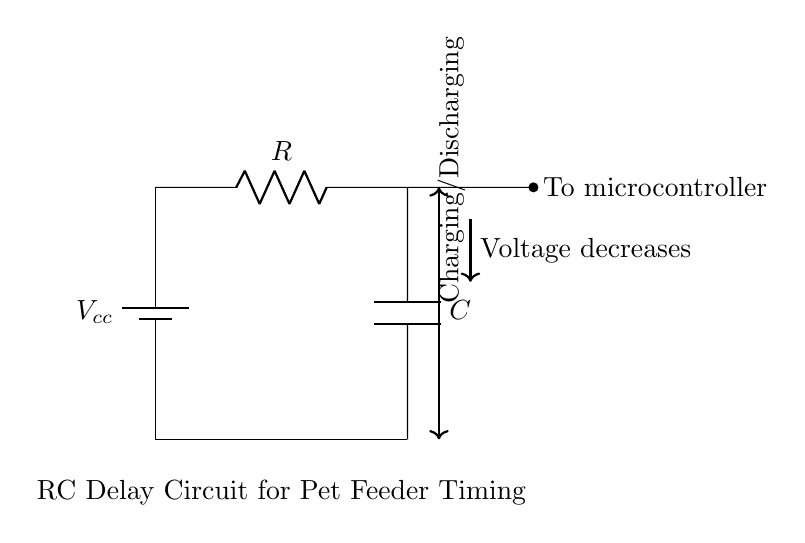What is the power source in this circuit? The circuit shows a battery symbol labeled as Vcc, indicating that the power source is a battery providing voltage to the circuit.
Answer: Battery What components are involved in this RC delay circuit? The circuit contains a resistor and a capacitor, which are essential for creating the delay. The resistor is labeled R, and the capacitor is labeled C.
Answer: Resistor and Capacitor What happens when the capacitor charges? When the capacitor charges, voltage across it increases and the current flowing through the resistor decreases until the capacitor reaches its maximum charge.
Answer: Voltage increases What is indicated by the arrow pointing down labeled as “Voltage decreases”? The arrow shows the direction of voltage drop across the capacitor as it discharges, indicating that the voltage decreases over time.
Answer: Voltage drop How does this circuit affect timing control for a pet feeder? The RC delay circuit can control timing by utilizing the time constant, which is defined by the resistor and capacitor values, therefore determining how long the delay lasts before the feeder activates.
Answer: Controls timing What does the labeling “To microcontroller” signify? The label indicates that the output of the RC circuit is connected to a microcontroller, which will use the voltage from the circuit to determine when to feed pets automatically.
Answer: Connected to microcontroller What is the function of the resistor in this RC circuit? The resistor limits the current flowing into the capacitor, affecting the charging and discharging time, thereby contributing to the timing of the delay circuit.
Answer: Limits current 